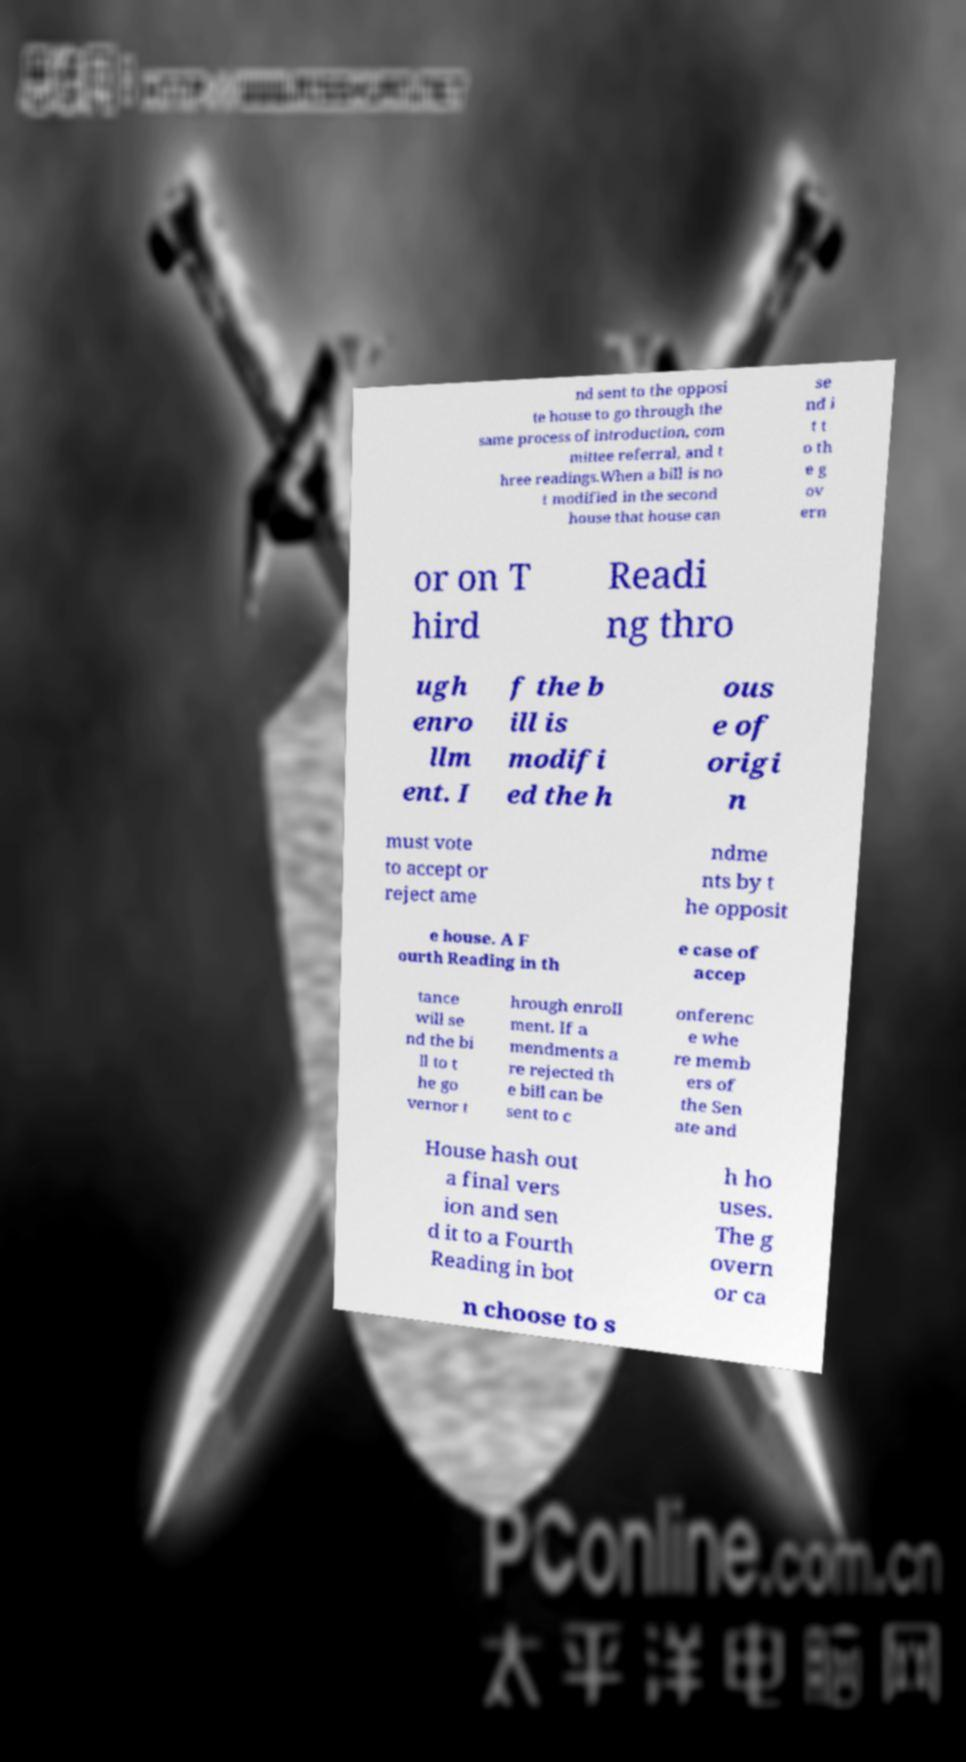For documentation purposes, I need the text within this image transcribed. Could you provide that? nd sent to the opposi te house to go through the same process of introduction, com mittee referral, and t hree readings.When a bill is no t modified in the second house that house can se nd i t t o th e g ov ern or on T hird Readi ng thro ugh enro llm ent. I f the b ill is modifi ed the h ous e of origi n must vote to accept or reject ame ndme nts by t he opposit e house. A F ourth Reading in th e case of accep tance will se nd the bi ll to t he go vernor t hrough enroll ment. If a mendments a re rejected th e bill can be sent to c onferenc e whe re memb ers of the Sen ate and House hash out a final vers ion and sen d it to a Fourth Reading in bot h ho uses. The g overn or ca n choose to s 